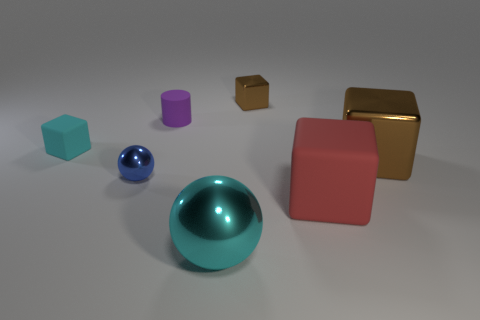What material is the tiny object that is both in front of the cylinder and behind the blue metal ball?
Offer a very short reply. Rubber. What is the shape of the cyan object that is on the left side of the big cyan metallic object?
Your answer should be very brief. Cube. There is a large metallic object on the left side of the metal cube on the right side of the red thing; what is its shape?
Offer a very short reply. Sphere. Is there a cyan object that has the same shape as the blue thing?
Keep it short and to the point. Yes. What shape is the cyan metal object that is the same size as the red matte block?
Keep it short and to the point. Sphere. Are there any big metallic things that are in front of the blue metallic object in front of the rubber object behind the cyan matte cube?
Provide a short and direct response. Yes. Are there any cyan metal things that have the same size as the blue thing?
Ensure brevity in your answer.  No. There is a cube that is on the left side of the large cyan ball; what is its size?
Keep it short and to the point. Small. The tiny metal thing on the right side of the small matte object to the right of the cyan object left of the cyan metallic ball is what color?
Your answer should be compact. Brown. There is a large metal thing on the left side of the large shiny object behind the blue object; what color is it?
Offer a terse response. Cyan. 